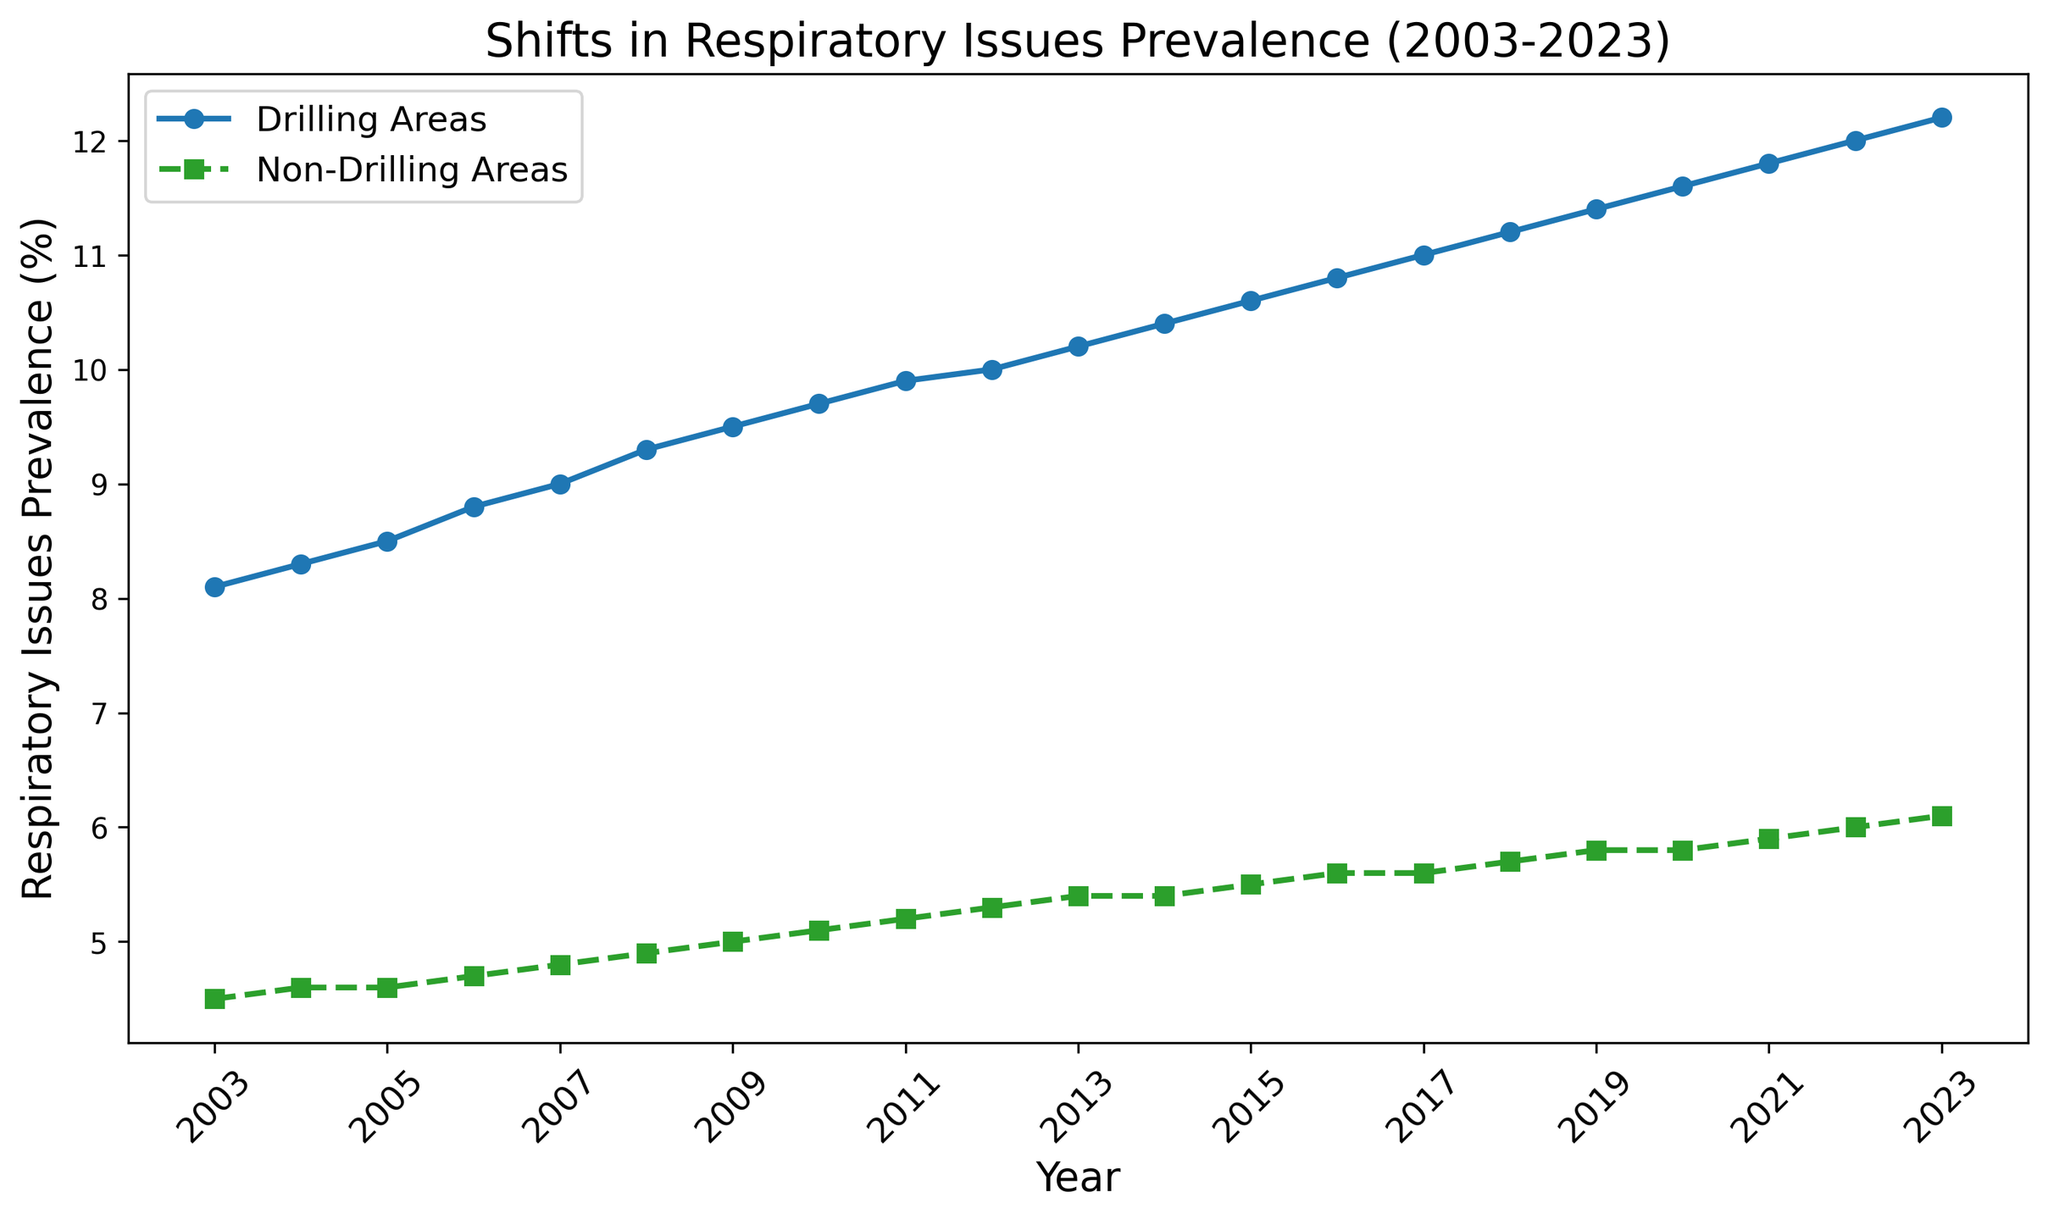What is the general trend of respiratory issues prevalence in drilling areas over the 20-year period? Examine the line representing drilling areas. Over the years from 2003 to 2023, it shows an upward trend, indicating an increase in respiratory issues prevalence.
Answer: Increasing In which year did respiratory issues in non-drilling areas reach 5.0%? Locate the line representing non-drilling areas and find the year where the y-axis value reaches 5.0%. This occurs in 2009.
Answer: 2009 What is the difference in respiratory issues prevalence between drilling and non-drilling areas in the year 2023? For 2023, subtract the non-drilling prevalence (6.1%) from the drilling prevalence (12.2%). The difference is 12.2% - 6.1% = 6.1%.
Answer: 6.1% What is the average prevalence of respiratory issues in non-drilling areas between 2003 and 2023? Sum the respiratory issues prevalence for all years in non-drilling areas and divide by the number of years (21). The sum is 4.5 + 4.6 + ... + 6.1 = 109.6. The average is 109.6 / 21 ≈ 5.22%.
Answer: 5.22% How many years did the prevalence of respiratory issues in drilling areas equal or exceed 10%? Examine the years where the drilling line is at or above 10%. These years are 2012, 2013, ..., and 2023, totaling 12 years.
Answer: 12 years By how much did the prevalence of respiratory issues in non-drilling areas change from 2003 to 2023? Subtract the non-drilling prevalence in 2003 (4.5%) from that in 2023 (6.1%). The change is 6.1% - 4.5% = 1.6%.
Answer: 1.6% Which year shows the highest prevalence of respiratory issues in non-drilling areas? Identify the peak value in the non-drilling line, which is in 2023 with 6.1%.
Answer: 2023 Was there any year when the prevalence of respiratory issues in drilling areas decreased compared to the previous year? Inspect the drilling line for any downward trends over consecutive years. The line consistently increases, so no such year exists.
Answer: No 